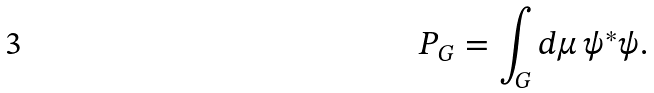<formula> <loc_0><loc_0><loc_500><loc_500>P _ { G } = \int _ { G } d \mu \, \psi ^ { * } \psi .</formula> 